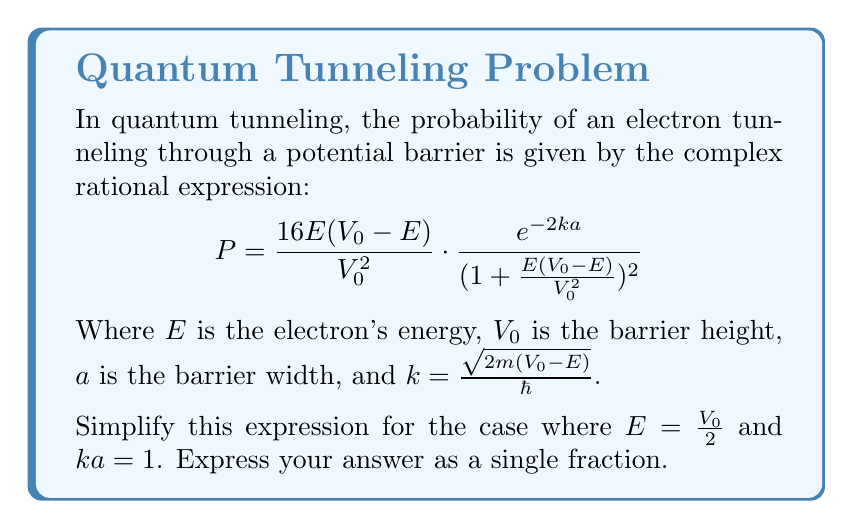Help me with this question. Let's approach this step-by-step:

1) First, let's substitute $E = \frac{V_0}{2}$ into the expression:

   $$P = \frac{16(\frac{V_0}{2})(V_0-\frac{V_0}{2})}{V_0^2} \cdot \frac{e^{-2ka}}{(1+\frac{\frac{V_0}{2}(V_0-\frac{V_0}{2})}{V_0^2})^2}$$

2) Simplify the numerator and denominator of the first fraction:
   
   $$P = \frac{16(\frac{V_0}{2})(\frac{V_0}{2})}{V_0^2} \cdot \frac{e^{-2ka}}{(1+\frac{\frac{V_0}{2}(\frac{V_0}{2})}{V_0^2})^2}$$

   $$P = \frac{16(\frac{V_0^2}{4})}{V_0^2} \cdot \frac{e^{-2ka}}{(1+\frac{V_0^2}{4V_0^2})^2}$$

   $$P = 4 \cdot \frac{e^{-2ka}}{(1+\frac{1}{4})^2}$$

3) Simplify the denominator of the second fraction:

   $$P = 4 \cdot \frac{e^{-2ka}}{(\frac{5}{4})^2}$$

   $$P = 4 \cdot \frac{e^{-2ka}}{\frac{25}{16}}$$

4) Now, substitute $ka = 1$:

   $$P = 4 \cdot \frac{e^{-2}}{\frac{25}{16}}$$

5) Multiply the fractions:

   $$P = 4 \cdot \frac{16e^{-2}}{25}$$

6) Simplify:

   $$P = \frac{64e^{-2}}{25}$$

This is our final simplified expression.
Answer: $\frac{64e^{-2}}{25}$ 